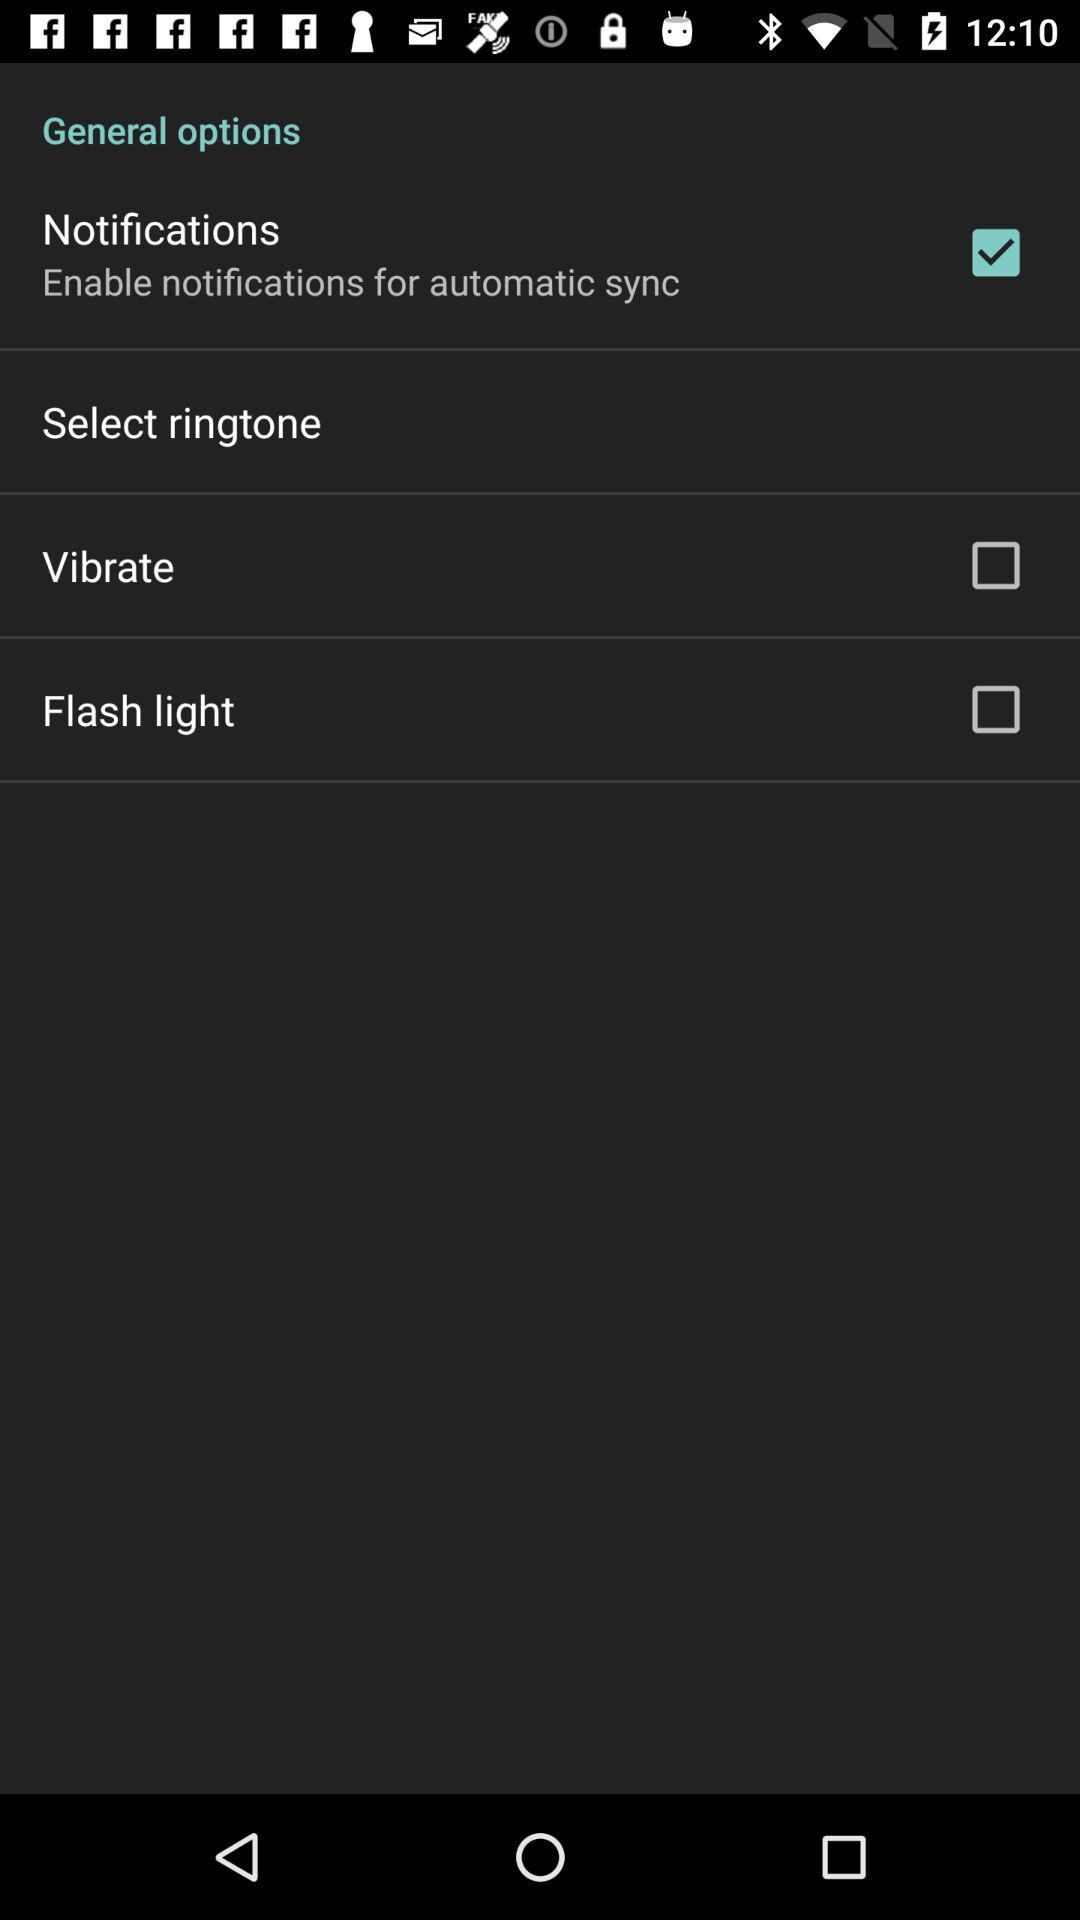What is the status of the notifications settings? The status is on. 